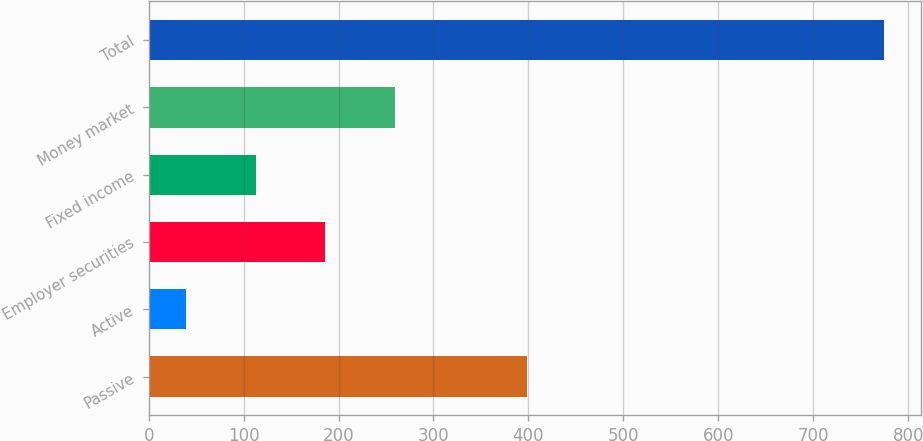Convert chart to OTSL. <chart><loc_0><loc_0><loc_500><loc_500><bar_chart><fcel>Passive<fcel>Active<fcel>Employer securities<fcel>Fixed income<fcel>Money market<fcel>Total<nl><fcel>398<fcel>39<fcel>186.2<fcel>112.6<fcel>259.8<fcel>775<nl></chart> 